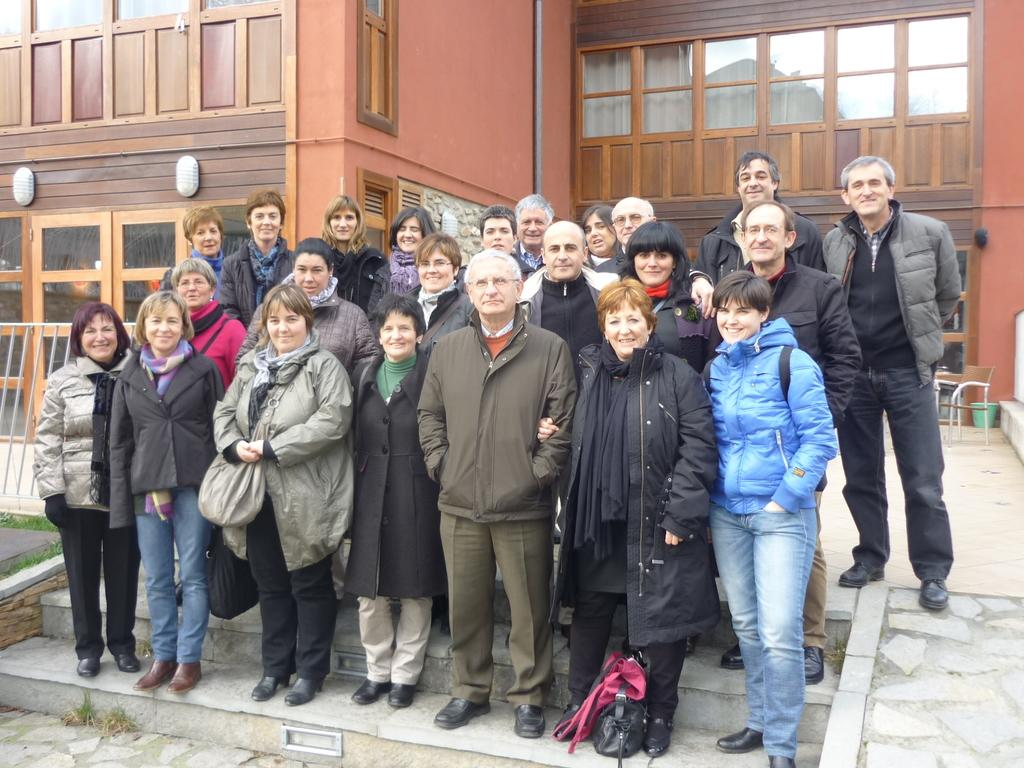How many people are in the image? There is a group of people in the image. Where are the people located in the image? The people are standing on stairs. What expressions do the people have in the image? The people have smiles on their faces. What can be seen in the background of the image? There is a building in the background of the image. What objects are in front of the building? There is a chair and a trash can in front of the building. What type of trail can be seen behind the people in the image? There is no trail visible in the image; it only shows a group of people standing on stairs, a building in the background, and a chair and trash can in front of the building. 